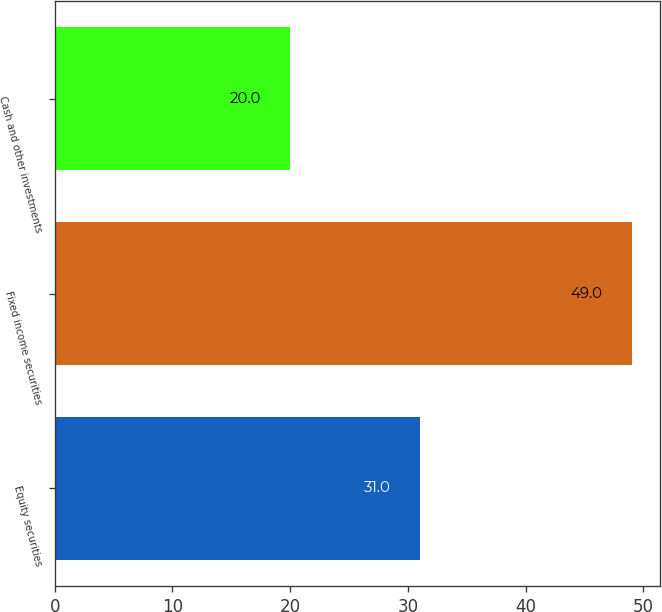<chart> <loc_0><loc_0><loc_500><loc_500><bar_chart><fcel>Equity securities<fcel>Fixed income securities<fcel>Cash and other investments<nl><fcel>31<fcel>49<fcel>20<nl></chart> 